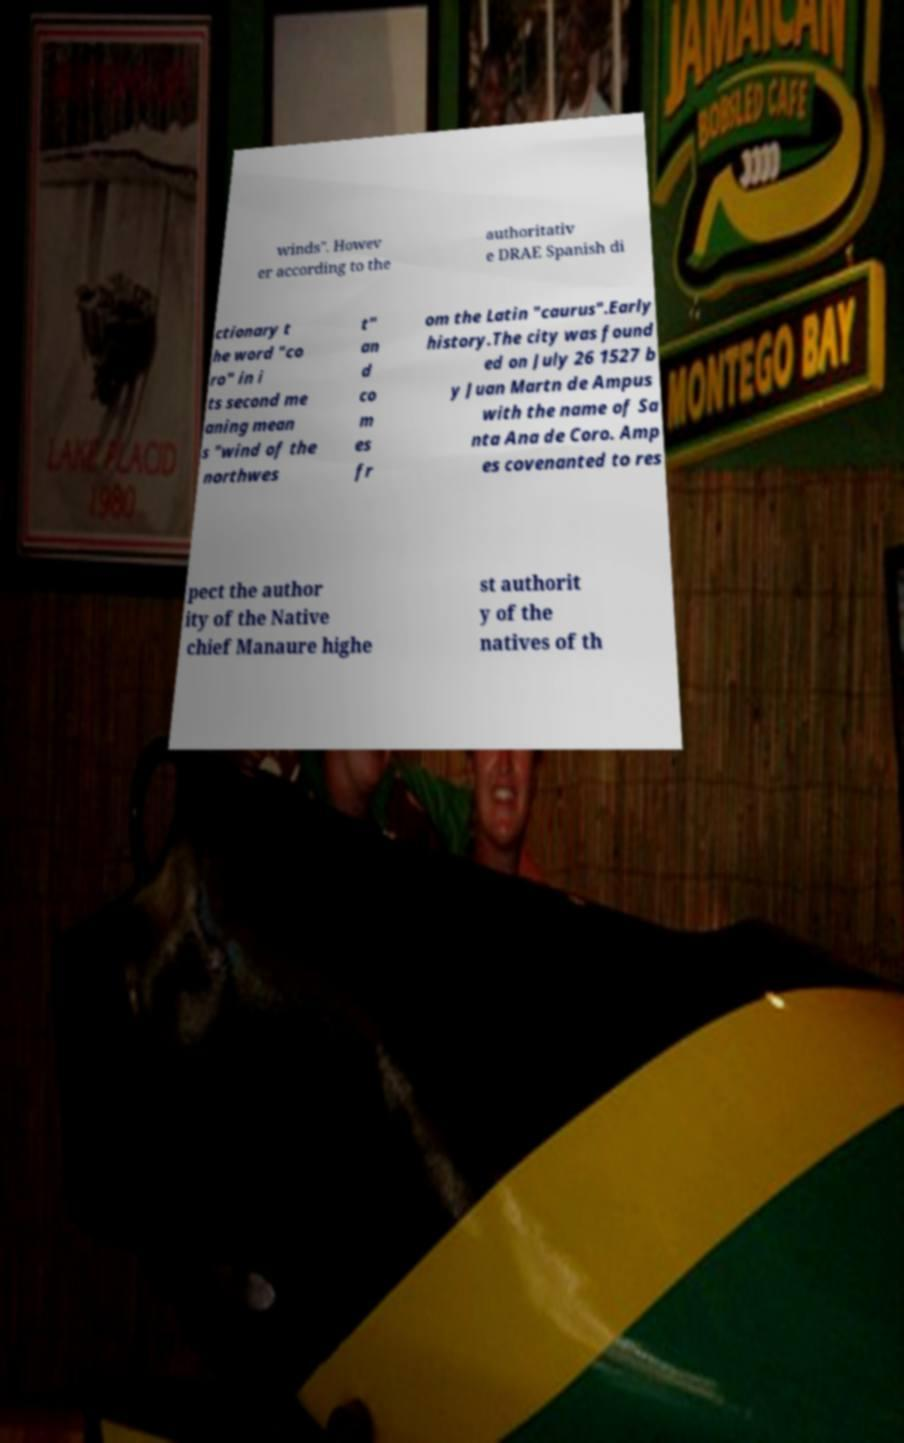Could you assist in decoding the text presented in this image and type it out clearly? winds". Howev er according to the authoritativ e DRAE Spanish di ctionary t he word "co ro" in i ts second me aning mean s "wind of the northwes t" an d co m es fr om the Latin "caurus".Early history.The city was found ed on July 26 1527 b y Juan Martn de Ampus with the name of Sa nta Ana de Coro. Amp es covenanted to res pect the author ity of the Native chief Manaure highe st authorit y of the natives of th 